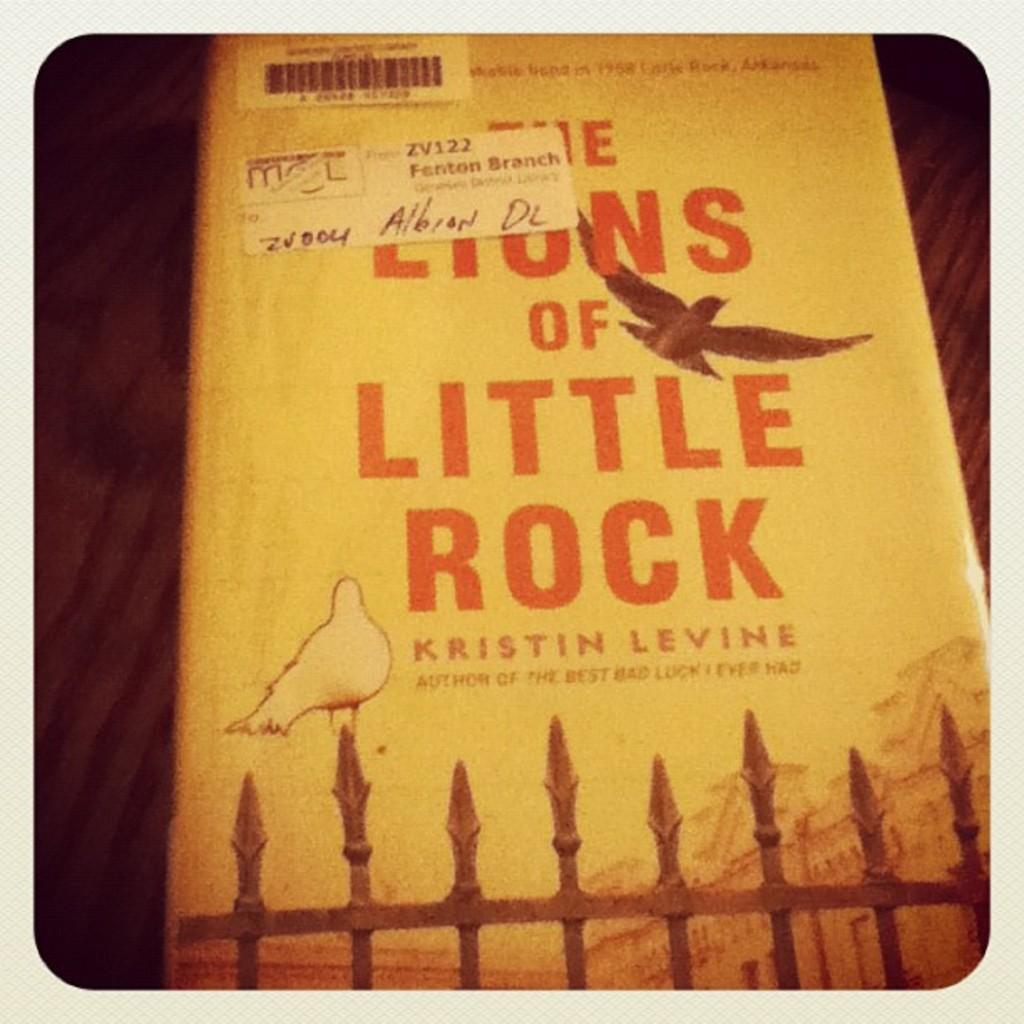<image>
Write a terse but informative summary of the picture. A Kristin Levine novel rests on a table top. 